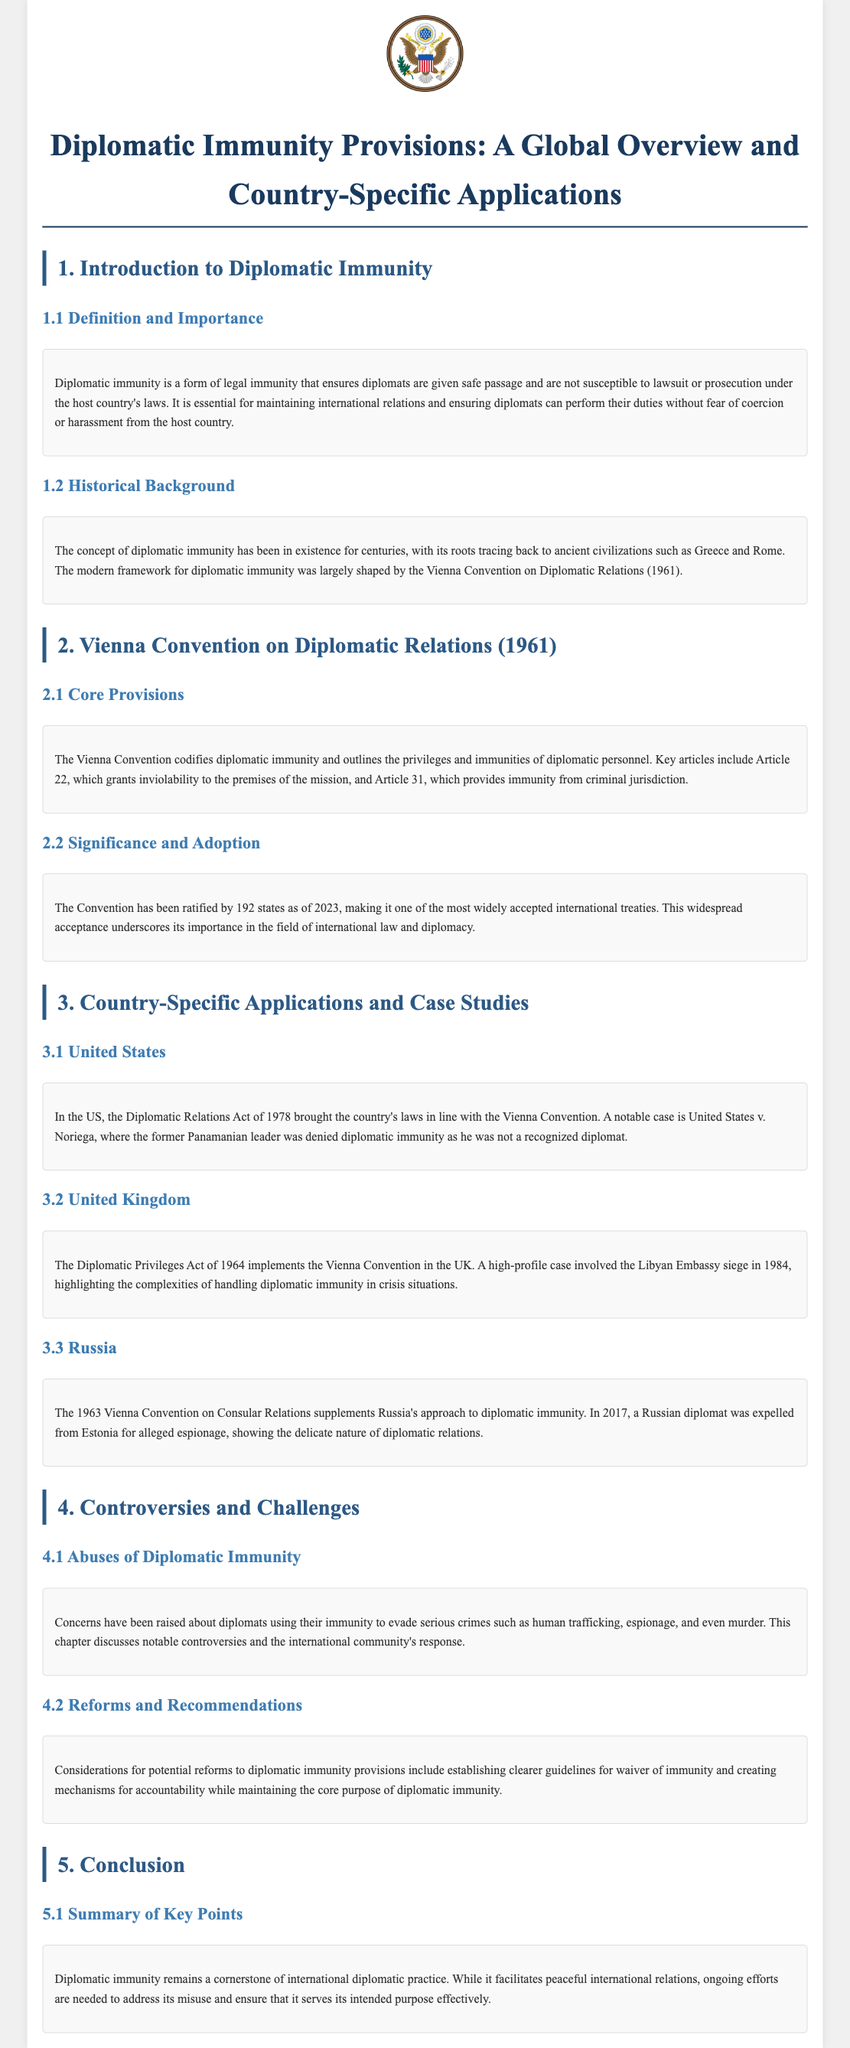What is the core document being discussed? The document provides an overview and specific applications of diplomatic immunity provisions worldwide.
Answer: Diplomatic Immunity Provisions: A Global Overview and Country-Specific Applications Which convention largely shaped the modern framework for diplomatic immunity? The document mentions the Vienna Convention as pivotal for the structure of diplomatic immunity.
Answer: Vienna Convention on Diplomatic Relations (1961) How many states have ratified the Vienna Convention as of 2023? The document states that 192 states have ratified the Convention.
Answer: 192 What act aligns the United States' laws with the Vienna Convention? The document references a specific act related to diplomatic relations in the United States.
Answer: Diplomatic Relations Act of 1978 What significant case involving the UK illustrates the complexities of diplomatic immunity? The document provides a case related to the UK and its diplomatic context.
Answer: Libyan Embassy siege in 1984 In what year was a Russian diplomat expelled from Estonia? The document provides a specific year related to an event concerning a Russian diplomat.
Answer: 2017 What issue is raised regarding the misuse of diplomatic immunity? The document discusses various serious crimes connected to diplomatic immunity misuse.
Answer: Human trafficking What type of recommendations does the document suggest regarding diplomatic immunity? It suggests potential reforms to increase accountability while maintaining core purposes.
Answer: Reforms and Recommendations What section follows the historical background of diplomatic immunity? The document has a specific structure that follows the historical background.
Answer: Vienna Convention on Diplomatic Relations (1961) 